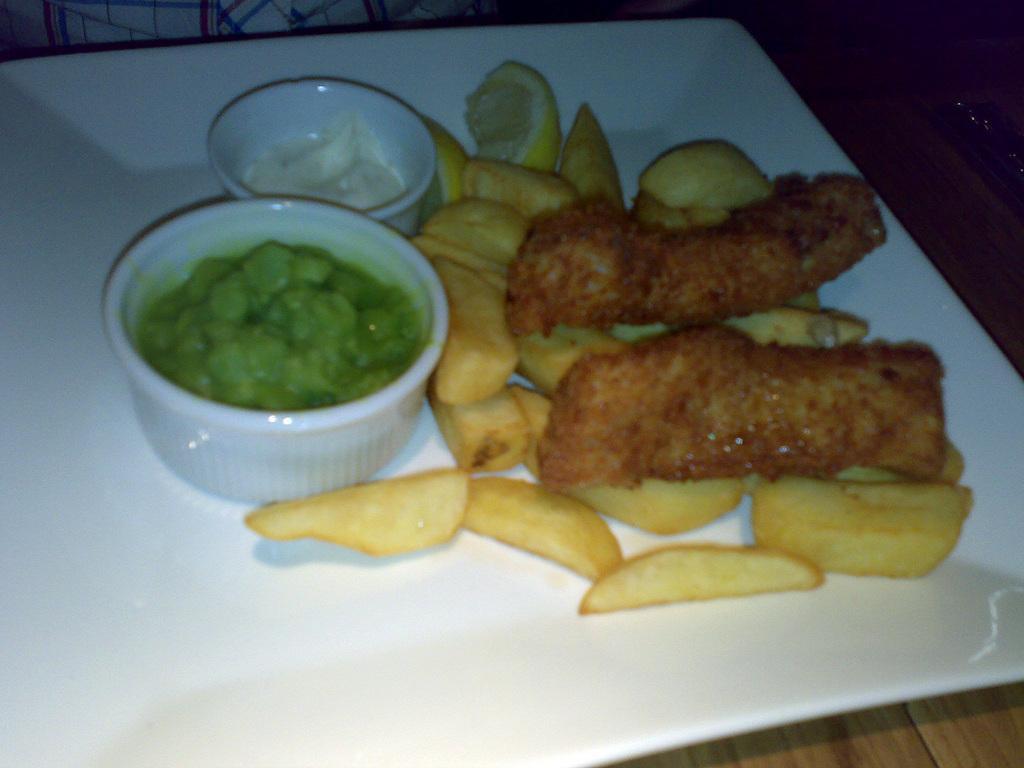Describe this image in one or two sentences. In this picture I can see there is some food placed on the plate and there are two bowls placed on the wooden table and in the backdrop I can see there is a man sitting. 